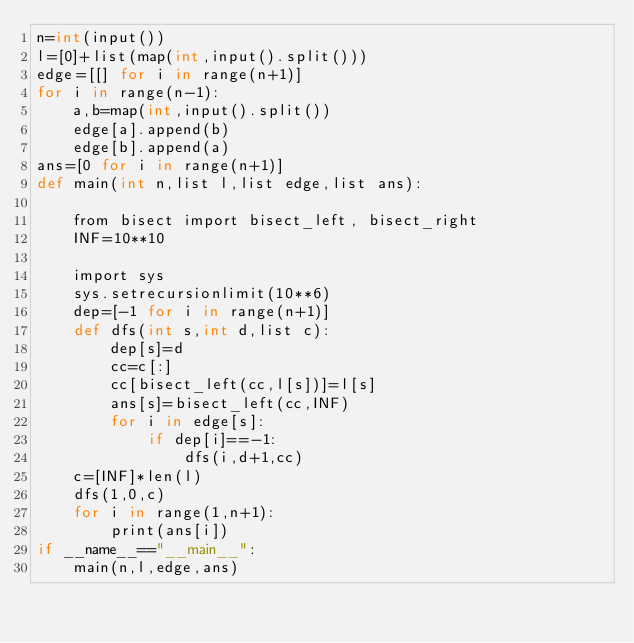Convert code to text. <code><loc_0><loc_0><loc_500><loc_500><_Cython_>n=int(input())
l=[0]+list(map(int,input().split()))
edge=[[] for i in range(n+1)]
for i in range(n-1):
    a,b=map(int,input().split())
    edge[a].append(b)
    edge[b].append(a)
ans=[0 for i in range(n+1)]
def main(int n,list l,list edge,list ans):

    from bisect import bisect_left, bisect_right
    INF=10**10

    import sys
    sys.setrecursionlimit(10**6)
    dep=[-1 for i in range(n+1)]
    def dfs(int s,int d,list c):
        dep[s]=d
        cc=c[:]
        cc[bisect_left(cc,l[s])]=l[s]
        ans[s]=bisect_left(cc,INF)
        for i in edge[s]:
            if dep[i]==-1:
                dfs(i,d+1,cc)
    c=[INF]*len(l)
    dfs(1,0,c)
    for i in range(1,n+1):
        print(ans[i])
if __name__=="__main__":
    main(n,l,edge,ans)</code> 